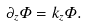Convert formula to latex. <formula><loc_0><loc_0><loc_500><loc_500>\partial _ { z } \Phi = k _ { z } \Phi .</formula> 